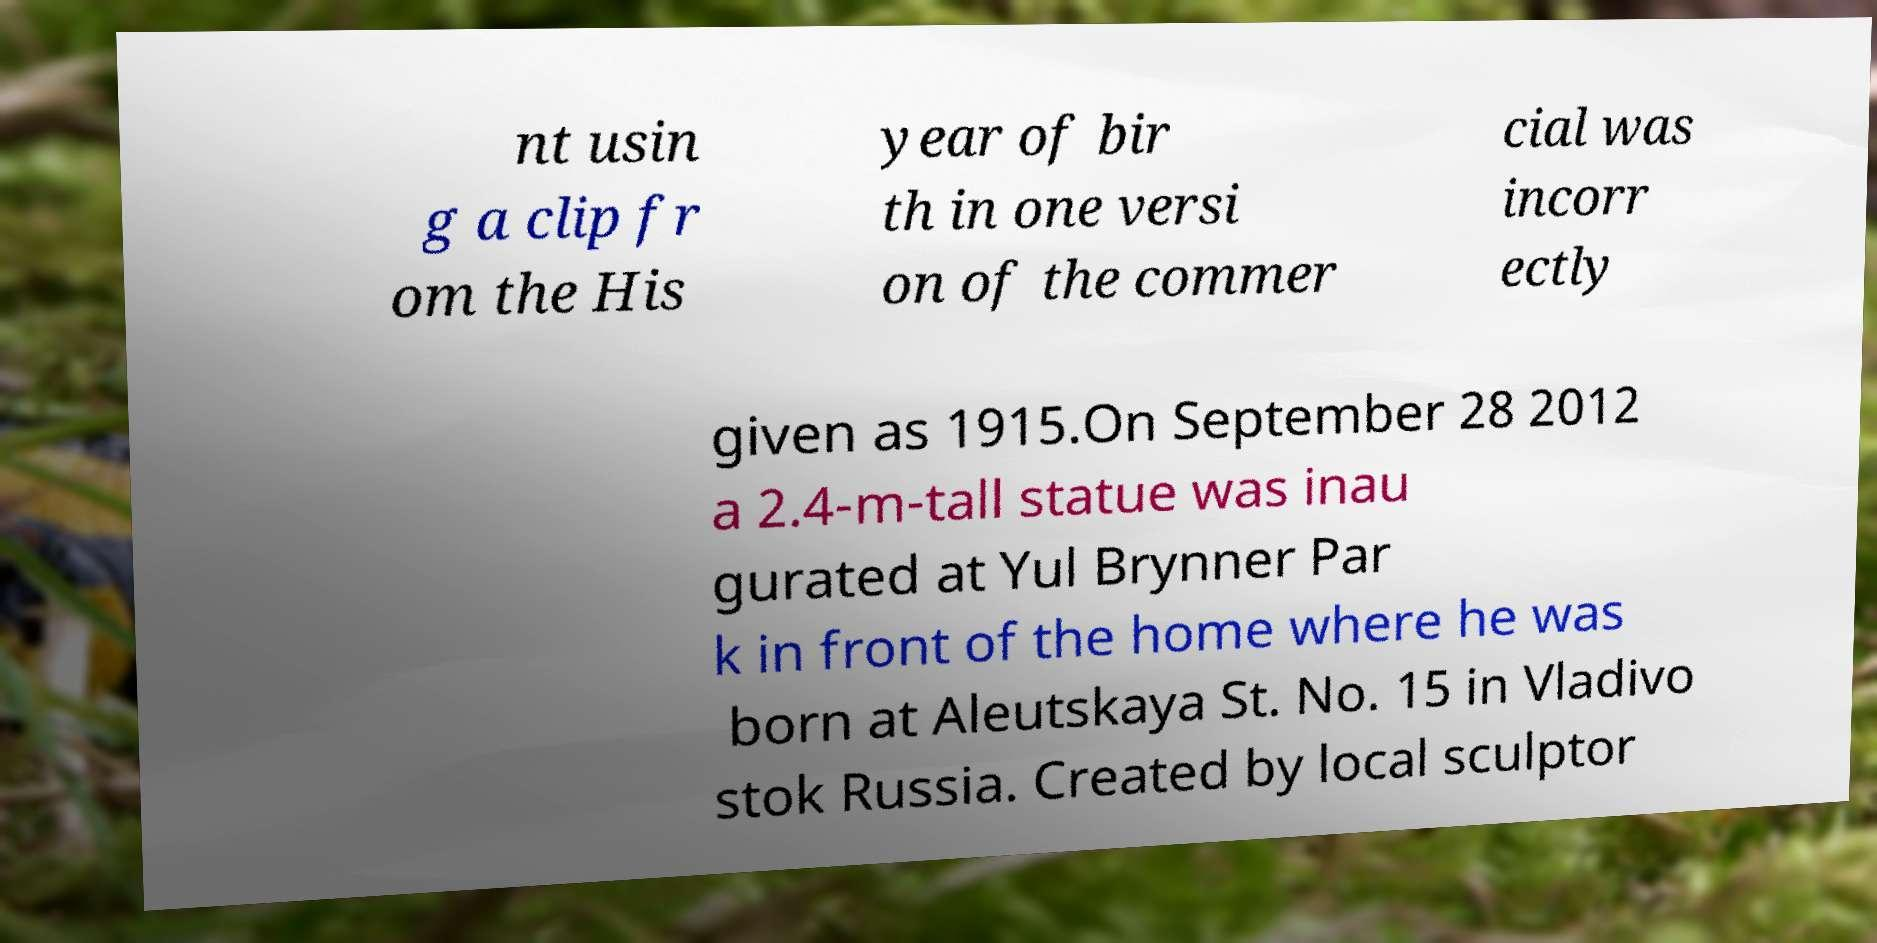Can you accurately transcribe the text from the provided image for me? nt usin g a clip fr om the His year of bir th in one versi on of the commer cial was incorr ectly given as 1915.On September 28 2012 a 2.4-m-tall statue was inau gurated at Yul Brynner Par k in front of the home where he was born at Aleutskaya St. No. 15 in Vladivo stok Russia. Created by local sculptor 